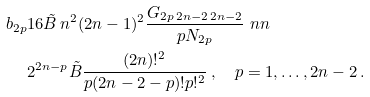<formula> <loc_0><loc_0><loc_500><loc_500>b _ { 2 p } & 1 6 \tilde { B } \, n ^ { 2 } ( 2 n - 1 ) ^ { 2 } \frac { G _ { 2 p \, 2 n - 2 \, 2 n - 2 } } { p N _ { 2 p } } \ n n \\ & 2 ^ { 2 n - p } \tilde { B } \frac { ( 2 n ) ! ^ { 2 } } { p ( 2 n - 2 - p ) ! p ! ^ { 2 } } \, , \quad p = 1 , \dots , 2 n - 2 \, .</formula> 